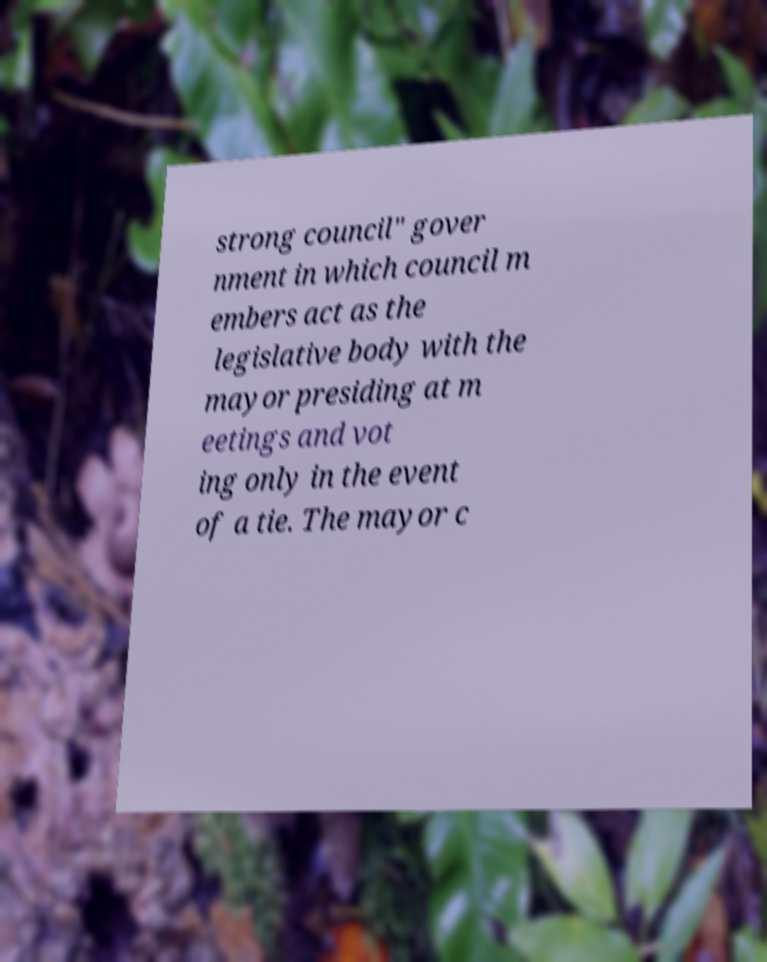Please read and relay the text visible in this image. What does it say? strong council" gover nment in which council m embers act as the legislative body with the mayor presiding at m eetings and vot ing only in the event of a tie. The mayor c 